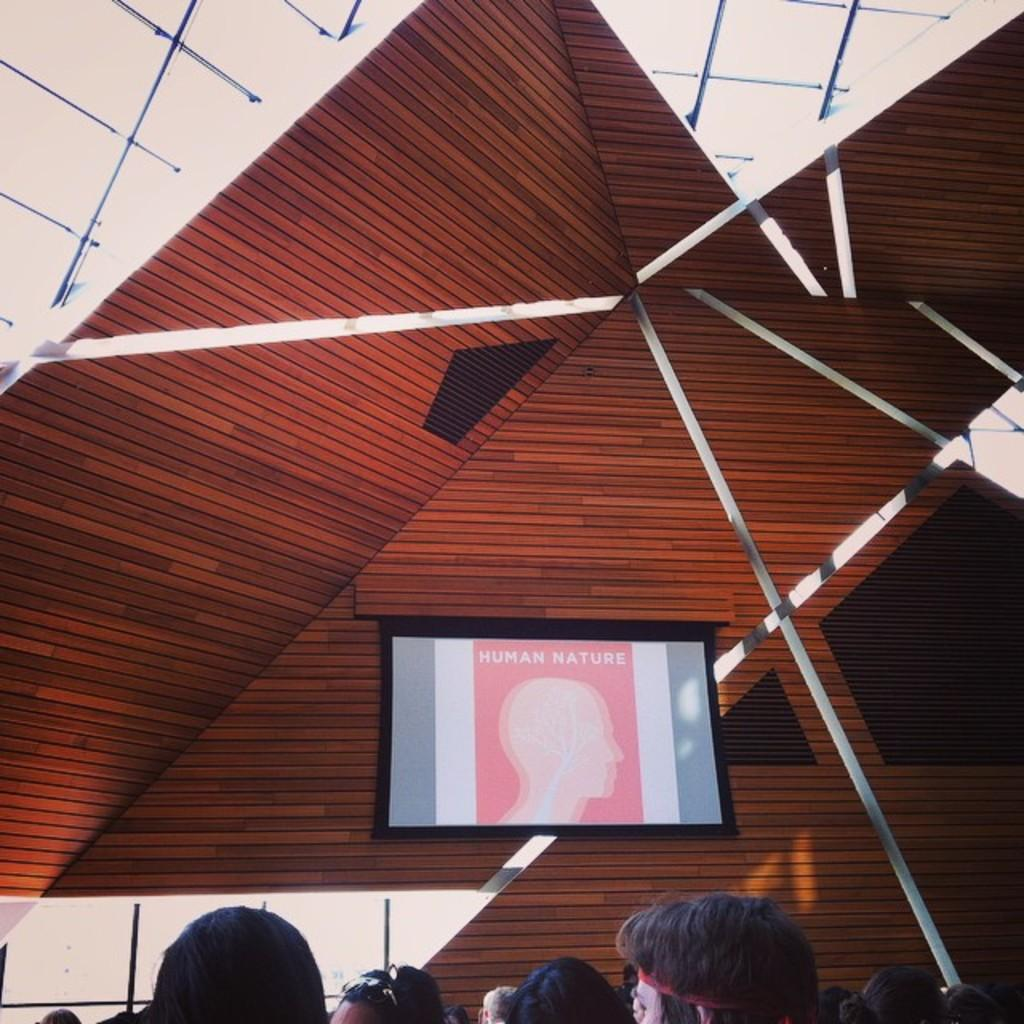What can be seen in the image that belongs to people? There are people's heads visible in the image. What is displayed on the screen in the image? There is a screen with an image and text in the image. What type of structure is visible in the image? There is a roof visible in the image. What architectural feature allows light to enter the structure in the image? There are windows visible in the image. How many babies are being held by the people in the image? There are no babies visible in the image; only people's heads can be seen. What type of experience can be gained from the image? The image does not offer any specific experience; it is a static representation of people's heads, a screen, a roof, and windows. 